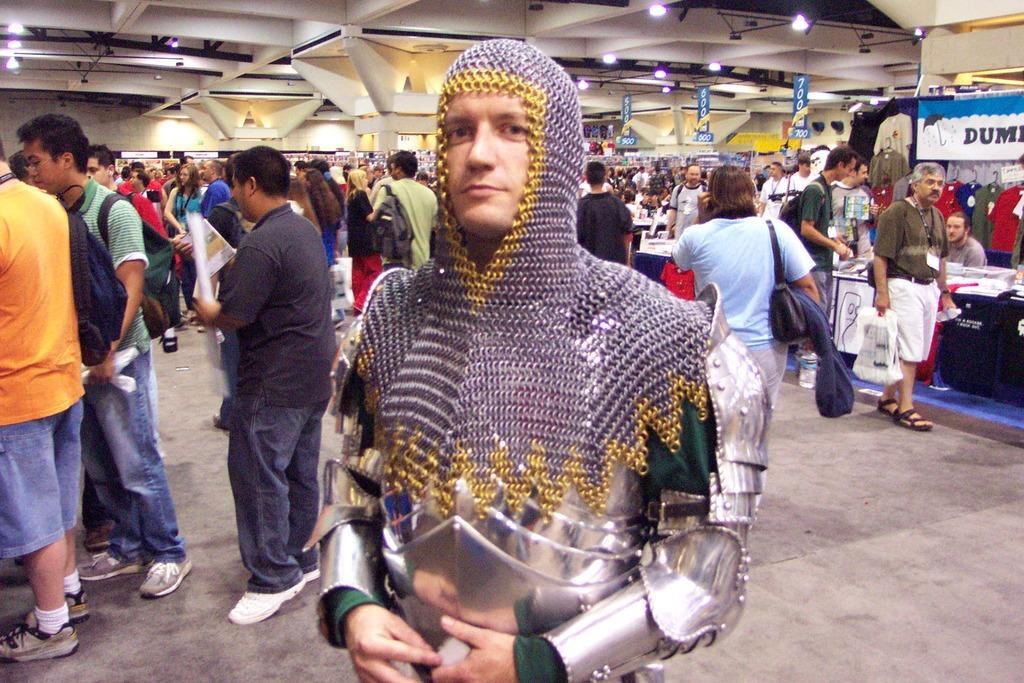Could you give a brief overview of what you see in this image? In this image In the foreground I can see a person wearing a colorful dress and in the background I can see crowd of people and tents and tables ,at the top I can see roofs and lights. 